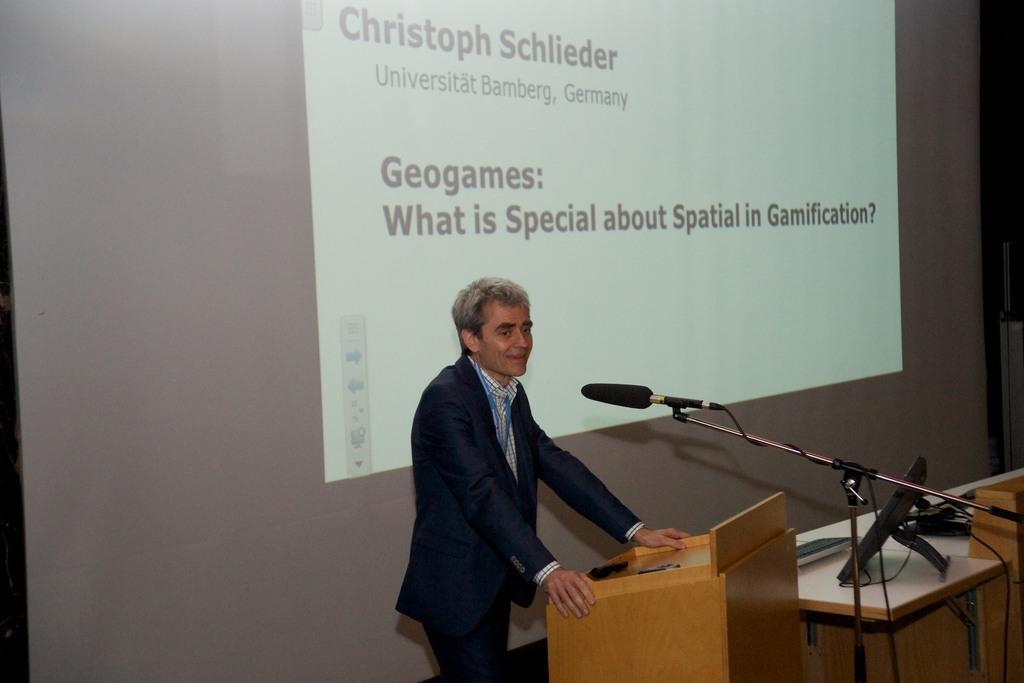Please provide a concise description of this image. The person is standing in front of a wooden table and there is a mic in front of him and there is a projected image behind him. 